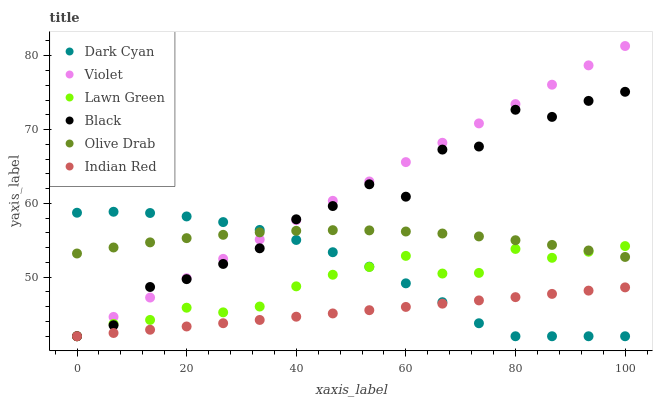Does Indian Red have the minimum area under the curve?
Answer yes or no. Yes. Does Violet have the maximum area under the curve?
Answer yes or no. Yes. Does Black have the minimum area under the curve?
Answer yes or no. No. Does Black have the maximum area under the curve?
Answer yes or no. No. Is Indian Red the smoothest?
Answer yes or no. Yes. Is Black the roughest?
Answer yes or no. Yes. Is Black the smoothest?
Answer yes or no. No. Is Indian Red the roughest?
Answer yes or no. No. Does Lawn Green have the lowest value?
Answer yes or no. Yes. Does Olive Drab have the lowest value?
Answer yes or no. No. Does Violet have the highest value?
Answer yes or no. Yes. Does Black have the highest value?
Answer yes or no. No. Is Indian Red less than Olive Drab?
Answer yes or no. Yes. Is Olive Drab greater than Indian Red?
Answer yes or no. Yes. Does Lawn Green intersect Olive Drab?
Answer yes or no. Yes. Is Lawn Green less than Olive Drab?
Answer yes or no. No. Is Lawn Green greater than Olive Drab?
Answer yes or no. No. Does Indian Red intersect Olive Drab?
Answer yes or no. No. 